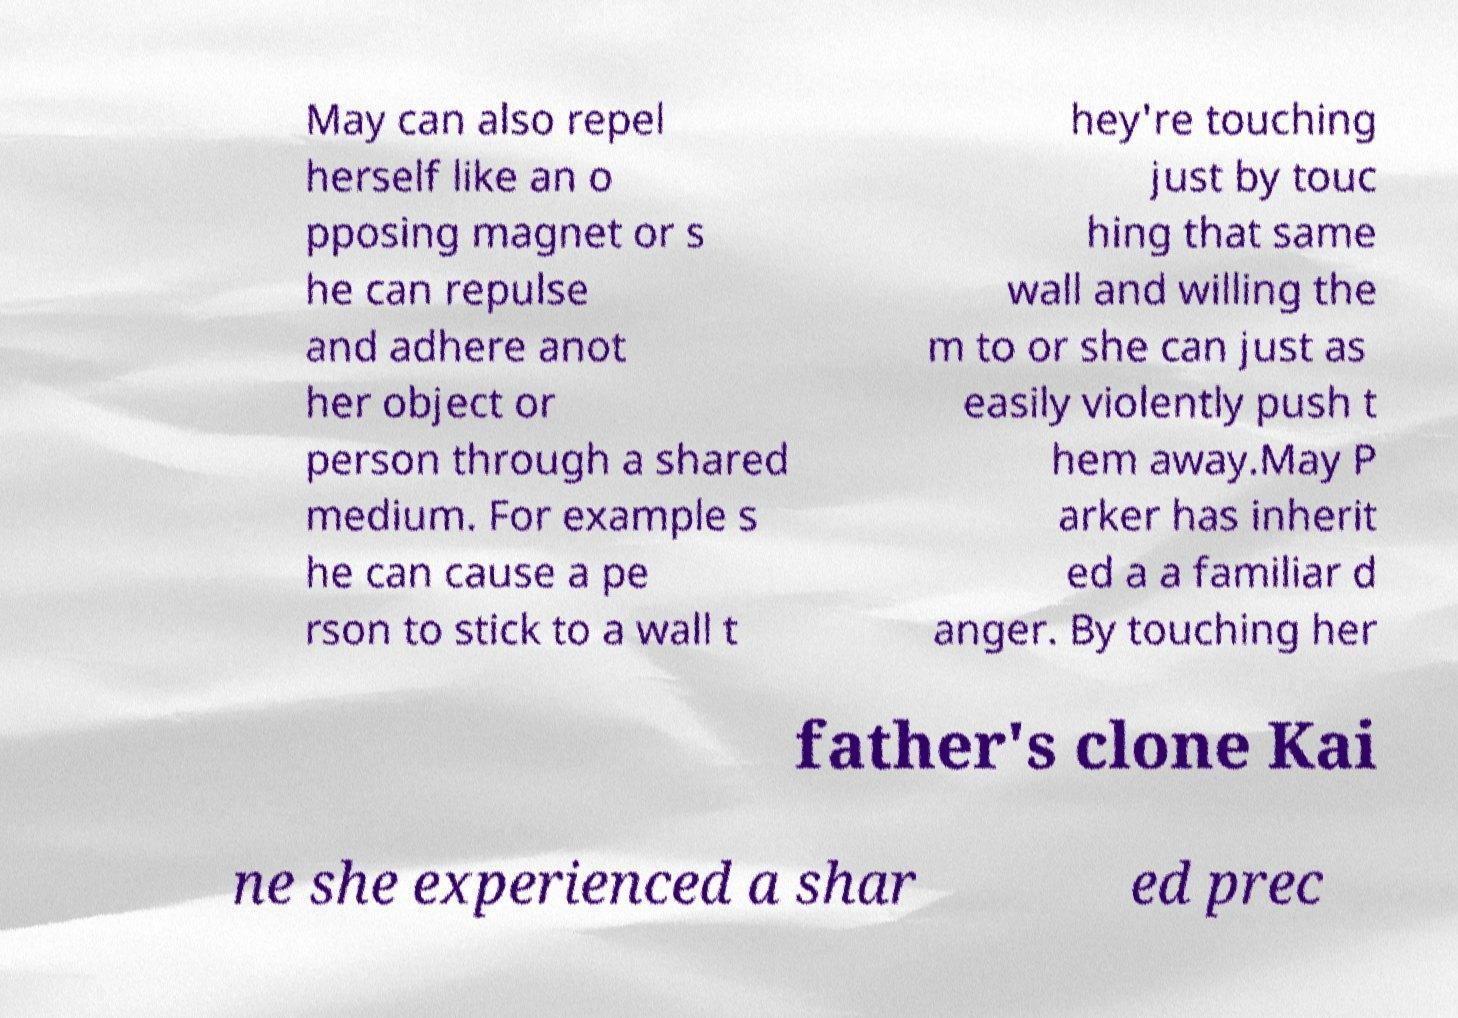Could you extract and type out the text from this image? May can also repel herself like an o pposing magnet or s he can repulse and adhere anot her object or person through a shared medium. For example s he can cause a pe rson to stick to a wall t hey're touching just by touc hing that same wall and willing the m to or she can just as easily violently push t hem away.May P arker has inherit ed a a familiar d anger. By touching her father's clone Kai ne she experienced a shar ed prec 